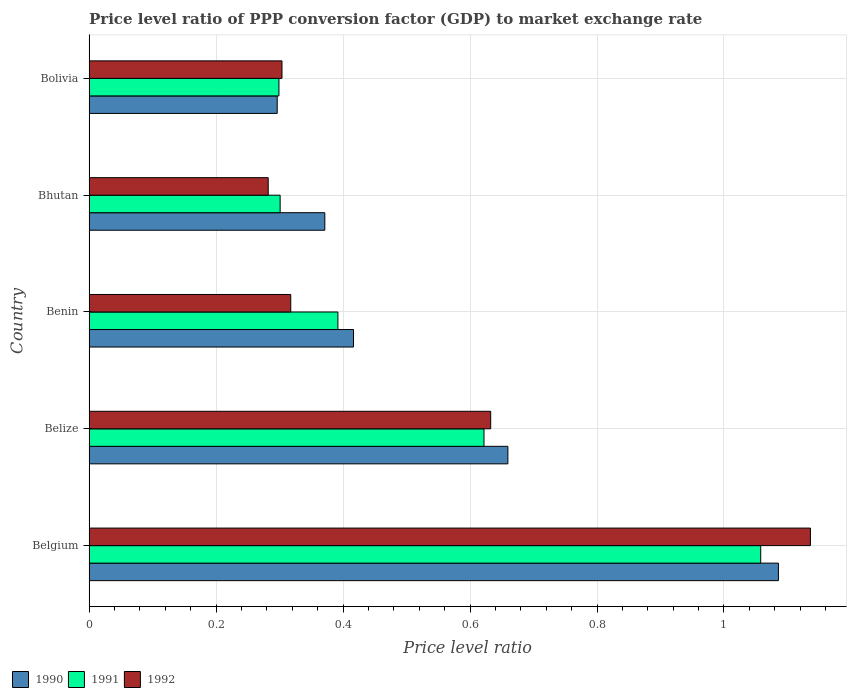How many different coloured bars are there?
Offer a very short reply. 3. Are the number of bars per tick equal to the number of legend labels?
Keep it short and to the point. Yes. How many bars are there on the 4th tick from the top?
Your response must be concise. 3. What is the label of the 4th group of bars from the top?
Your response must be concise. Belize. What is the price level ratio in 1992 in Belgium?
Ensure brevity in your answer.  1.14. Across all countries, what is the maximum price level ratio in 1990?
Give a very brief answer. 1.09. Across all countries, what is the minimum price level ratio in 1990?
Give a very brief answer. 0.3. In which country was the price level ratio in 1990 minimum?
Provide a succinct answer. Bolivia. What is the total price level ratio in 1990 in the graph?
Ensure brevity in your answer.  2.83. What is the difference between the price level ratio in 1992 in Belize and that in Bhutan?
Offer a terse response. 0.35. What is the difference between the price level ratio in 1991 in Bhutan and the price level ratio in 1992 in Belize?
Ensure brevity in your answer.  -0.33. What is the average price level ratio in 1990 per country?
Ensure brevity in your answer.  0.57. What is the difference between the price level ratio in 1992 and price level ratio in 1990 in Belgium?
Provide a short and direct response. 0.05. What is the ratio of the price level ratio in 1990 in Belize to that in Bolivia?
Make the answer very short. 2.23. Is the difference between the price level ratio in 1992 in Benin and Bolivia greater than the difference between the price level ratio in 1990 in Benin and Bolivia?
Ensure brevity in your answer.  No. What is the difference between the highest and the second highest price level ratio in 1992?
Offer a terse response. 0.5. What is the difference between the highest and the lowest price level ratio in 1991?
Offer a terse response. 0.76. In how many countries, is the price level ratio in 1990 greater than the average price level ratio in 1990 taken over all countries?
Your answer should be compact. 2. What does the 2nd bar from the bottom in Benin represents?
Offer a terse response. 1991. How many bars are there?
Offer a very short reply. 15. Are all the bars in the graph horizontal?
Provide a short and direct response. Yes. What is the title of the graph?
Keep it short and to the point. Price level ratio of PPP conversion factor (GDP) to market exchange rate. Does "1962" appear as one of the legend labels in the graph?
Make the answer very short. No. What is the label or title of the X-axis?
Provide a succinct answer. Price level ratio. What is the Price level ratio of 1990 in Belgium?
Provide a short and direct response. 1.09. What is the Price level ratio of 1991 in Belgium?
Provide a short and direct response. 1.06. What is the Price level ratio in 1992 in Belgium?
Offer a very short reply. 1.14. What is the Price level ratio in 1990 in Belize?
Ensure brevity in your answer.  0.66. What is the Price level ratio in 1991 in Belize?
Your answer should be compact. 0.62. What is the Price level ratio of 1992 in Belize?
Ensure brevity in your answer.  0.63. What is the Price level ratio in 1990 in Benin?
Offer a very short reply. 0.42. What is the Price level ratio of 1991 in Benin?
Make the answer very short. 0.39. What is the Price level ratio of 1992 in Benin?
Offer a very short reply. 0.32. What is the Price level ratio of 1990 in Bhutan?
Provide a short and direct response. 0.37. What is the Price level ratio in 1991 in Bhutan?
Your answer should be compact. 0.3. What is the Price level ratio in 1992 in Bhutan?
Offer a terse response. 0.28. What is the Price level ratio in 1990 in Bolivia?
Make the answer very short. 0.3. What is the Price level ratio in 1991 in Bolivia?
Ensure brevity in your answer.  0.3. What is the Price level ratio of 1992 in Bolivia?
Your answer should be compact. 0.3. Across all countries, what is the maximum Price level ratio in 1990?
Make the answer very short. 1.09. Across all countries, what is the maximum Price level ratio in 1991?
Give a very brief answer. 1.06. Across all countries, what is the maximum Price level ratio in 1992?
Provide a short and direct response. 1.14. Across all countries, what is the minimum Price level ratio in 1990?
Offer a terse response. 0.3. Across all countries, what is the minimum Price level ratio of 1991?
Provide a short and direct response. 0.3. Across all countries, what is the minimum Price level ratio in 1992?
Your answer should be compact. 0.28. What is the total Price level ratio in 1990 in the graph?
Your answer should be very brief. 2.83. What is the total Price level ratio of 1991 in the graph?
Provide a short and direct response. 2.67. What is the total Price level ratio in 1992 in the graph?
Your answer should be very brief. 2.67. What is the difference between the Price level ratio of 1990 in Belgium and that in Belize?
Your answer should be very brief. 0.43. What is the difference between the Price level ratio in 1991 in Belgium and that in Belize?
Your answer should be compact. 0.44. What is the difference between the Price level ratio in 1992 in Belgium and that in Belize?
Give a very brief answer. 0.5. What is the difference between the Price level ratio in 1990 in Belgium and that in Benin?
Your response must be concise. 0.67. What is the difference between the Price level ratio in 1991 in Belgium and that in Benin?
Offer a very short reply. 0.67. What is the difference between the Price level ratio of 1992 in Belgium and that in Benin?
Offer a terse response. 0.82. What is the difference between the Price level ratio in 1990 in Belgium and that in Bhutan?
Provide a short and direct response. 0.71. What is the difference between the Price level ratio of 1991 in Belgium and that in Bhutan?
Your response must be concise. 0.76. What is the difference between the Price level ratio of 1992 in Belgium and that in Bhutan?
Offer a very short reply. 0.85. What is the difference between the Price level ratio of 1990 in Belgium and that in Bolivia?
Offer a terse response. 0.79. What is the difference between the Price level ratio of 1991 in Belgium and that in Bolivia?
Your answer should be compact. 0.76. What is the difference between the Price level ratio in 1992 in Belgium and that in Bolivia?
Offer a very short reply. 0.83. What is the difference between the Price level ratio of 1990 in Belize and that in Benin?
Provide a succinct answer. 0.24. What is the difference between the Price level ratio of 1991 in Belize and that in Benin?
Offer a terse response. 0.23. What is the difference between the Price level ratio of 1992 in Belize and that in Benin?
Your answer should be very brief. 0.31. What is the difference between the Price level ratio of 1990 in Belize and that in Bhutan?
Ensure brevity in your answer.  0.29. What is the difference between the Price level ratio in 1991 in Belize and that in Bhutan?
Your response must be concise. 0.32. What is the difference between the Price level ratio of 1992 in Belize and that in Bhutan?
Keep it short and to the point. 0.35. What is the difference between the Price level ratio in 1990 in Belize and that in Bolivia?
Your response must be concise. 0.36. What is the difference between the Price level ratio of 1991 in Belize and that in Bolivia?
Your answer should be very brief. 0.32. What is the difference between the Price level ratio in 1992 in Belize and that in Bolivia?
Ensure brevity in your answer.  0.33. What is the difference between the Price level ratio in 1990 in Benin and that in Bhutan?
Give a very brief answer. 0.05. What is the difference between the Price level ratio in 1991 in Benin and that in Bhutan?
Keep it short and to the point. 0.09. What is the difference between the Price level ratio of 1992 in Benin and that in Bhutan?
Give a very brief answer. 0.04. What is the difference between the Price level ratio in 1990 in Benin and that in Bolivia?
Your answer should be compact. 0.12. What is the difference between the Price level ratio in 1991 in Benin and that in Bolivia?
Your answer should be compact. 0.09. What is the difference between the Price level ratio of 1992 in Benin and that in Bolivia?
Your answer should be compact. 0.01. What is the difference between the Price level ratio of 1990 in Bhutan and that in Bolivia?
Your answer should be compact. 0.07. What is the difference between the Price level ratio in 1991 in Bhutan and that in Bolivia?
Offer a very short reply. 0. What is the difference between the Price level ratio of 1992 in Bhutan and that in Bolivia?
Ensure brevity in your answer.  -0.02. What is the difference between the Price level ratio in 1990 in Belgium and the Price level ratio in 1991 in Belize?
Your answer should be very brief. 0.46. What is the difference between the Price level ratio in 1990 in Belgium and the Price level ratio in 1992 in Belize?
Keep it short and to the point. 0.45. What is the difference between the Price level ratio of 1991 in Belgium and the Price level ratio of 1992 in Belize?
Provide a short and direct response. 0.43. What is the difference between the Price level ratio in 1990 in Belgium and the Price level ratio in 1991 in Benin?
Keep it short and to the point. 0.69. What is the difference between the Price level ratio in 1990 in Belgium and the Price level ratio in 1992 in Benin?
Provide a short and direct response. 0.77. What is the difference between the Price level ratio of 1991 in Belgium and the Price level ratio of 1992 in Benin?
Offer a terse response. 0.74. What is the difference between the Price level ratio in 1990 in Belgium and the Price level ratio in 1991 in Bhutan?
Your answer should be compact. 0.78. What is the difference between the Price level ratio of 1990 in Belgium and the Price level ratio of 1992 in Bhutan?
Your answer should be very brief. 0.8. What is the difference between the Price level ratio of 1991 in Belgium and the Price level ratio of 1992 in Bhutan?
Provide a succinct answer. 0.78. What is the difference between the Price level ratio in 1990 in Belgium and the Price level ratio in 1991 in Bolivia?
Ensure brevity in your answer.  0.79. What is the difference between the Price level ratio of 1990 in Belgium and the Price level ratio of 1992 in Bolivia?
Provide a short and direct response. 0.78. What is the difference between the Price level ratio in 1991 in Belgium and the Price level ratio in 1992 in Bolivia?
Your response must be concise. 0.75. What is the difference between the Price level ratio in 1990 in Belize and the Price level ratio in 1991 in Benin?
Keep it short and to the point. 0.27. What is the difference between the Price level ratio in 1990 in Belize and the Price level ratio in 1992 in Benin?
Offer a terse response. 0.34. What is the difference between the Price level ratio of 1991 in Belize and the Price level ratio of 1992 in Benin?
Keep it short and to the point. 0.3. What is the difference between the Price level ratio of 1990 in Belize and the Price level ratio of 1991 in Bhutan?
Ensure brevity in your answer.  0.36. What is the difference between the Price level ratio in 1990 in Belize and the Price level ratio in 1992 in Bhutan?
Make the answer very short. 0.38. What is the difference between the Price level ratio in 1991 in Belize and the Price level ratio in 1992 in Bhutan?
Offer a terse response. 0.34. What is the difference between the Price level ratio of 1990 in Belize and the Price level ratio of 1991 in Bolivia?
Offer a terse response. 0.36. What is the difference between the Price level ratio in 1990 in Belize and the Price level ratio in 1992 in Bolivia?
Offer a terse response. 0.36. What is the difference between the Price level ratio in 1991 in Belize and the Price level ratio in 1992 in Bolivia?
Ensure brevity in your answer.  0.32. What is the difference between the Price level ratio of 1990 in Benin and the Price level ratio of 1991 in Bhutan?
Your answer should be very brief. 0.12. What is the difference between the Price level ratio of 1990 in Benin and the Price level ratio of 1992 in Bhutan?
Give a very brief answer. 0.13. What is the difference between the Price level ratio of 1991 in Benin and the Price level ratio of 1992 in Bhutan?
Ensure brevity in your answer.  0.11. What is the difference between the Price level ratio of 1990 in Benin and the Price level ratio of 1991 in Bolivia?
Make the answer very short. 0.12. What is the difference between the Price level ratio in 1990 in Benin and the Price level ratio in 1992 in Bolivia?
Ensure brevity in your answer.  0.11. What is the difference between the Price level ratio of 1991 in Benin and the Price level ratio of 1992 in Bolivia?
Offer a terse response. 0.09. What is the difference between the Price level ratio of 1990 in Bhutan and the Price level ratio of 1991 in Bolivia?
Your response must be concise. 0.07. What is the difference between the Price level ratio in 1990 in Bhutan and the Price level ratio in 1992 in Bolivia?
Offer a terse response. 0.07. What is the difference between the Price level ratio in 1991 in Bhutan and the Price level ratio in 1992 in Bolivia?
Offer a very short reply. -0. What is the average Price level ratio in 1990 per country?
Keep it short and to the point. 0.57. What is the average Price level ratio in 1991 per country?
Give a very brief answer. 0.53. What is the average Price level ratio in 1992 per country?
Provide a short and direct response. 0.53. What is the difference between the Price level ratio in 1990 and Price level ratio in 1991 in Belgium?
Ensure brevity in your answer.  0.03. What is the difference between the Price level ratio in 1990 and Price level ratio in 1992 in Belgium?
Offer a very short reply. -0.05. What is the difference between the Price level ratio of 1991 and Price level ratio of 1992 in Belgium?
Provide a succinct answer. -0.08. What is the difference between the Price level ratio in 1990 and Price level ratio in 1991 in Belize?
Give a very brief answer. 0.04. What is the difference between the Price level ratio of 1990 and Price level ratio of 1992 in Belize?
Your response must be concise. 0.03. What is the difference between the Price level ratio in 1991 and Price level ratio in 1992 in Belize?
Your answer should be compact. -0.01. What is the difference between the Price level ratio in 1990 and Price level ratio in 1991 in Benin?
Give a very brief answer. 0.02. What is the difference between the Price level ratio in 1990 and Price level ratio in 1992 in Benin?
Give a very brief answer. 0.1. What is the difference between the Price level ratio of 1991 and Price level ratio of 1992 in Benin?
Keep it short and to the point. 0.07. What is the difference between the Price level ratio in 1990 and Price level ratio in 1991 in Bhutan?
Keep it short and to the point. 0.07. What is the difference between the Price level ratio of 1990 and Price level ratio of 1992 in Bhutan?
Provide a succinct answer. 0.09. What is the difference between the Price level ratio in 1991 and Price level ratio in 1992 in Bhutan?
Make the answer very short. 0.02. What is the difference between the Price level ratio of 1990 and Price level ratio of 1991 in Bolivia?
Your response must be concise. -0. What is the difference between the Price level ratio of 1990 and Price level ratio of 1992 in Bolivia?
Provide a succinct answer. -0.01. What is the difference between the Price level ratio of 1991 and Price level ratio of 1992 in Bolivia?
Make the answer very short. -0. What is the ratio of the Price level ratio in 1990 in Belgium to that in Belize?
Offer a terse response. 1.65. What is the ratio of the Price level ratio of 1991 in Belgium to that in Belize?
Your answer should be very brief. 1.7. What is the ratio of the Price level ratio of 1992 in Belgium to that in Belize?
Provide a succinct answer. 1.8. What is the ratio of the Price level ratio in 1990 in Belgium to that in Benin?
Offer a terse response. 2.61. What is the ratio of the Price level ratio of 1991 in Belgium to that in Benin?
Provide a succinct answer. 2.7. What is the ratio of the Price level ratio of 1992 in Belgium to that in Benin?
Provide a succinct answer. 3.58. What is the ratio of the Price level ratio of 1990 in Belgium to that in Bhutan?
Provide a succinct answer. 2.92. What is the ratio of the Price level ratio of 1991 in Belgium to that in Bhutan?
Give a very brief answer. 3.52. What is the ratio of the Price level ratio of 1992 in Belgium to that in Bhutan?
Make the answer very short. 4.03. What is the ratio of the Price level ratio of 1990 in Belgium to that in Bolivia?
Give a very brief answer. 3.66. What is the ratio of the Price level ratio of 1991 in Belgium to that in Bolivia?
Provide a succinct answer. 3.54. What is the ratio of the Price level ratio in 1992 in Belgium to that in Bolivia?
Provide a succinct answer. 3.74. What is the ratio of the Price level ratio of 1990 in Belize to that in Benin?
Offer a very short reply. 1.58. What is the ratio of the Price level ratio in 1991 in Belize to that in Benin?
Offer a terse response. 1.59. What is the ratio of the Price level ratio in 1992 in Belize to that in Benin?
Your answer should be compact. 1.99. What is the ratio of the Price level ratio of 1990 in Belize to that in Bhutan?
Ensure brevity in your answer.  1.78. What is the ratio of the Price level ratio in 1991 in Belize to that in Bhutan?
Give a very brief answer. 2.07. What is the ratio of the Price level ratio in 1992 in Belize to that in Bhutan?
Ensure brevity in your answer.  2.24. What is the ratio of the Price level ratio in 1990 in Belize to that in Bolivia?
Provide a short and direct response. 2.23. What is the ratio of the Price level ratio in 1991 in Belize to that in Bolivia?
Your answer should be very brief. 2.08. What is the ratio of the Price level ratio of 1992 in Belize to that in Bolivia?
Provide a succinct answer. 2.08. What is the ratio of the Price level ratio in 1990 in Benin to that in Bhutan?
Offer a very short reply. 1.12. What is the ratio of the Price level ratio of 1991 in Benin to that in Bhutan?
Your answer should be very brief. 1.3. What is the ratio of the Price level ratio in 1992 in Benin to that in Bhutan?
Offer a very short reply. 1.13. What is the ratio of the Price level ratio in 1990 in Benin to that in Bolivia?
Your answer should be very brief. 1.41. What is the ratio of the Price level ratio of 1991 in Benin to that in Bolivia?
Provide a succinct answer. 1.31. What is the ratio of the Price level ratio in 1992 in Benin to that in Bolivia?
Keep it short and to the point. 1.05. What is the ratio of the Price level ratio of 1990 in Bhutan to that in Bolivia?
Keep it short and to the point. 1.25. What is the ratio of the Price level ratio of 1991 in Bhutan to that in Bolivia?
Your answer should be compact. 1.01. What is the ratio of the Price level ratio in 1992 in Bhutan to that in Bolivia?
Provide a short and direct response. 0.93. What is the difference between the highest and the second highest Price level ratio in 1990?
Give a very brief answer. 0.43. What is the difference between the highest and the second highest Price level ratio of 1991?
Your answer should be compact. 0.44. What is the difference between the highest and the second highest Price level ratio in 1992?
Provide a short and direct response. 0.5. What is the difference between the highest and the lowest Price level ratio in 1990?
Give a very brief answer. 0.79. What is the difference between the highest and the lowest Price level ratio of 1991?
Your answer should be compact. 0.76. What is the difference between the highest and the lowest Price level ratio in 1992?
Offer a very short reply. 0.85. 